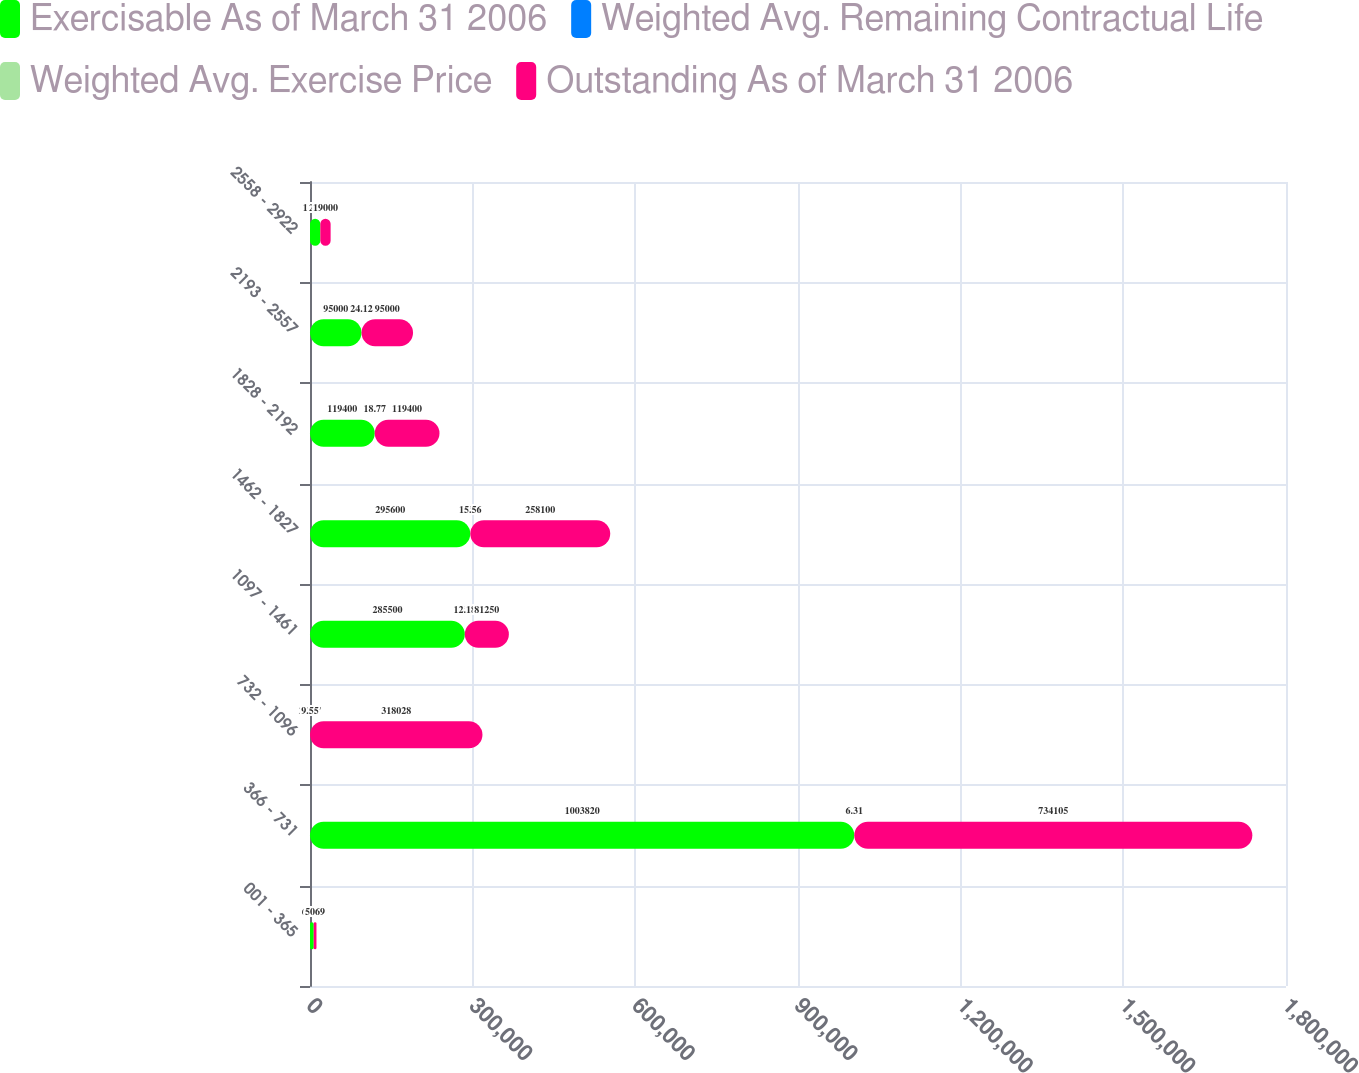Convert chart to OTSL. <chart><loc_0><loc_0><loc_500><loc_500><stacked_bar_chart><ecel><fcel>001 - 365<fcel>366 - 731<fcel>732 - 1096<fcel>1097 - 1461<fcel>1462 - 1827<fcel>1828 - 2192<fcel>2193 - 2557<fcel>2558 - 2922<nl><fcel>Exercisable As of March 31 2006<fcel>6848<fcel>1.00382e+06<fcel>27.17<fcel>285500<fcel>295600<fcel>119400<fcel>95000<fcel>19000<nl><fcel>Weighted Avg. Remaining Contractual Life<fcel>7.8<fcel>4.7<fcel>8.8<fcel>8<fcel>5<fcel>4.6<fcel>5.2<fcel>3.9<nl><fcel>Weighted Avg. Exercise Price<fcel>0.01<fcel>6.31<fcel>9.55<fcel>12.18<fcel>15.56<fcel>18.77<fcel>24.12<fcel>27.17<nl><fcel>Outstanding As of March 31 2006<fcel>5069<fcel>734105<fcel>318028<fcel>81250<fcel>258100<fcel>119400<fcel>95000<fcel>19000<nl></chart> 